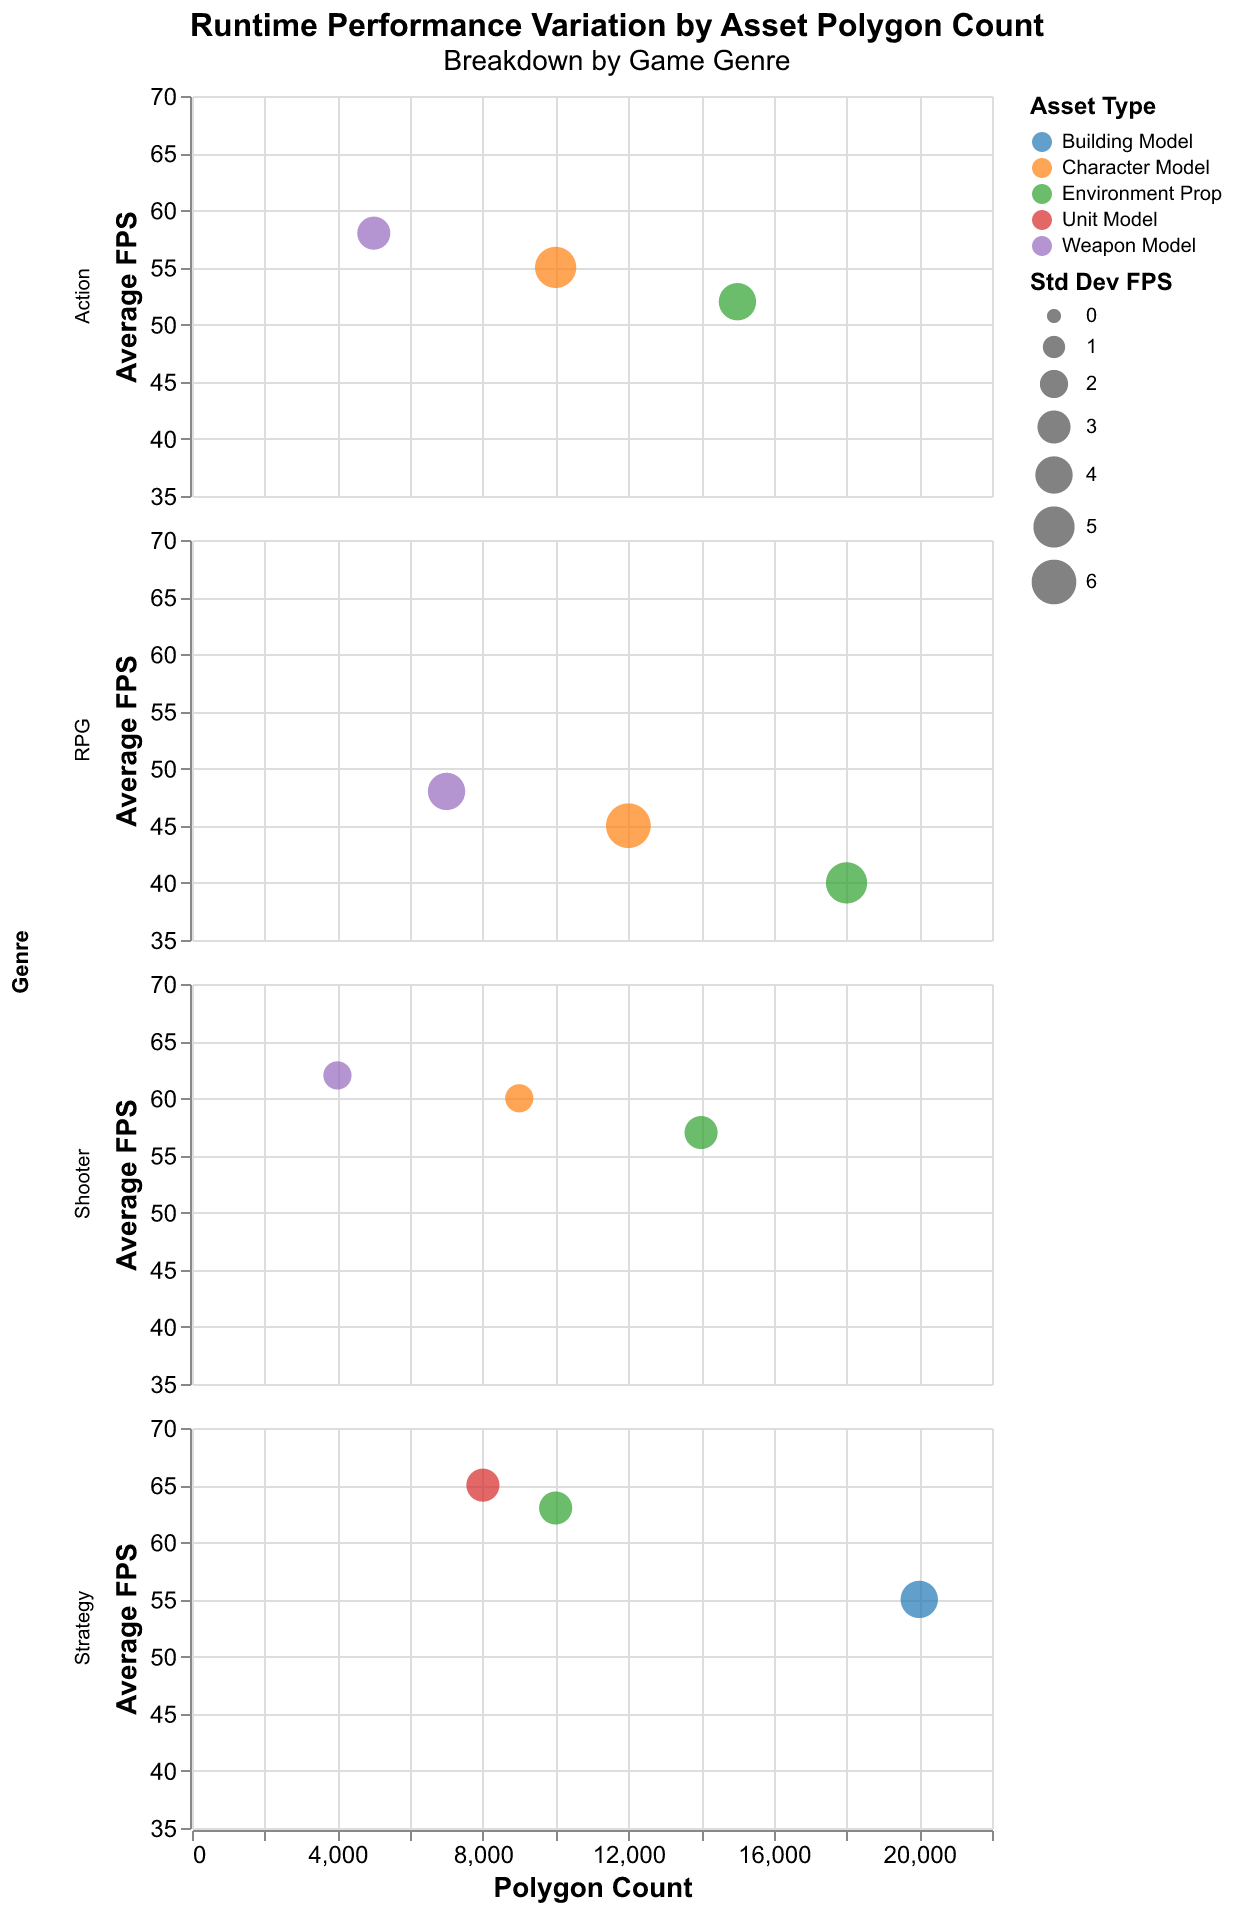What is the title of the figure? The title is generally at the top of the figure, providing a summary of what the figure represents. In this case, the title is provided in the code.
Answer: "Runtime Performance Variation by Asset Polygon Count" Which genre has the highest average FPS for any asset type? To find this, look at each genre's subplot and identify the highest average FPS. The Shooter genre (Call of Duty) has a Weapon Model with 62 FPS.
Answer: Shooter How does the polygon count correlate with the average FPS for the RPG genre? Examine the RPG genre plot. As the polygon count increases (Character Model: 12000, Environment Prop: 18000), the average FPS decreases (Character Model: 45 FPS, Environment Prop: 40 FPS) indicating a negative correlation.
Answer: Negatively What asset in the Strategy genre has the highest polygon count and what is its average FPS? Identify the asset with the highest polygon count in the Strategy genre plot first. The Building Model has the highest polygon count of 20,000, and its average FPS is 55.
Answer: Building Model, 55 FPS Which genre shows the greatest variation in average FPS across its assets? Observing the spread of FPS values within each genre, the RPG genre has the widest range between the lowest (40 FPS for Environment Prop) and highest (48 FPS for Weapon Model) values.
Answer: RPG For the Action genre, what is the average FPS deviation for the Character Model? The figure shows that the average FPS deviation (Std Dev FPS) for the Action genre's Character Model (Assassin's Creed) is 5.
Answer: 5 Which asset type generally has the largest standard deviation in FPS? By observing the bubble sizes, larger bubbles represent higher standard deviations. Character Model in the RPG genre has a larger size, indicating it has the highest standard deviation (6).
Answer: RPG Character Model Compare the average FPS of the Weapon Models across all genres. Which genre's Weapon Model performs best? Look at all bubble positions for Weapon Models across genres. Shooter (Call of Duty) has the highest average FPS for Weapon Model at 62.
Answer: Shooter What is the general trend for average FPS as the polygon count increases in the Strategy genre? Examine the Strategy genre subplot and note how average FPS changes with polygon count. As polygon count increases from Unit Model (8000 polygons, 65 FPS) to Building Model (20000 polygons, 55 FPS), FPS generally decreases.
Answer: Decreasing Based on the figure, what relationship can you infer between polygon count and performance for Asset models in Shooter games? In the Shooter genre, as the polygon count decreases from Environment Prop (14000 polygons) to Character Model (9000 polygons) to Weapon Model (4000 polygons), the average FPS increases from 57 to 60 to 62 respectively. This shows a clear inverse relationship.
Answer: Inversely proportional 